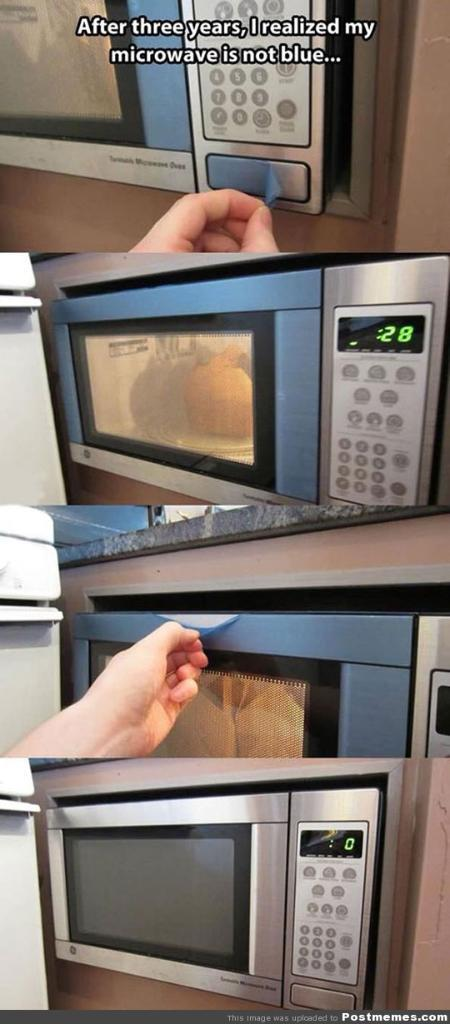What type of picture is in the image? There is a collage picture in the image. What is depicted in the collage picture? The collage picture contains a person. What is the person holding in the collage picture? The person is holding a microwave oven. What type of fog can be seen in the image? There is no fog present in the image; it features a collage picture with a person holding a microwave oven. 